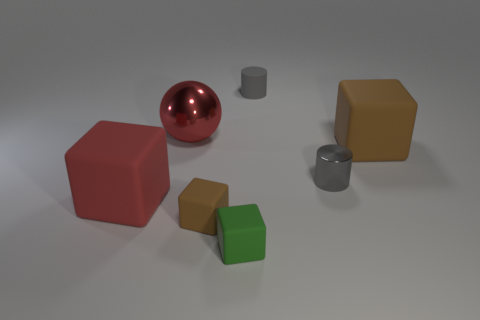Imagine this is a still from an animation. Can you create a storyline involving these objects? Certainly! In a colorful digital world, the red sphere is a playful character embarking on a journey to discover its place within the shapes. Guided by the wise green cube and the friendly brown cube, the sphere learns about cooperation and diversity as it interacts with the twin gray cylinders, which turn out to be keys to unlocking the path to a harmonious geometric kingdom. 